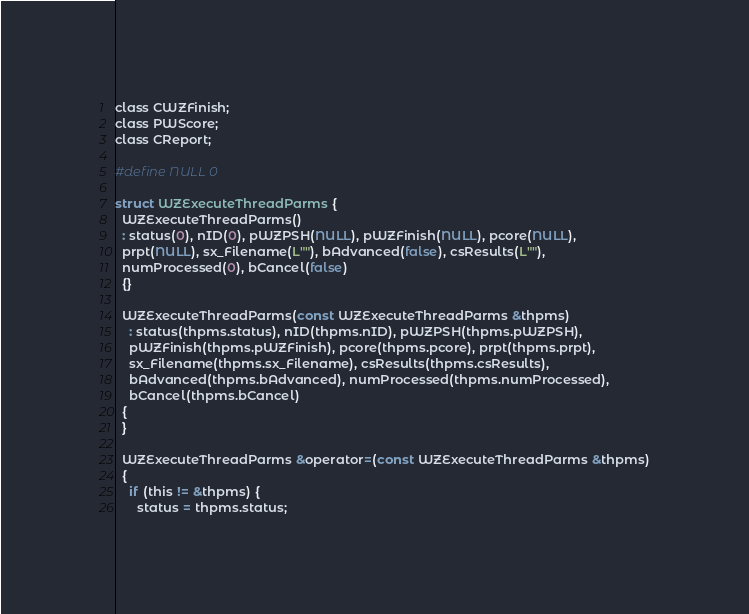<code> <loc_0><loc_0><loc_500><loc_500><_C_>class CWZFinish;
class PWScore;
class CReport;

#define NULL 0

struct WZExecuteThreadParms {
  WZExecuteThreadParms()
  : status(0), nID(0), pWZPSH(NULL), pWZFinish(NULL), pcore(NULL),
  prpt(NULL), sx_Filename(L""), bAdvanced(false), csResults(L""),
  numProcessed(0), bCancel(false)
  {}

  WZExecuteThreadParms(const WZExecuteThreadParms &thpms)
    : status(thpms.status), nID(thpms.nID), pWZPSH(thpms.pWZPSH),
    pWZFinish(thpms.pWZFinish), pcore(thpms.pcore), prpt(thpms.prpt),
    sx_Filename(thpms.sx_Filename), csResults(thpms.csResults),
    bAdvanced(thpms.bAdvanced), numProcessed(thpms.numProcessed),
    bCancel(thpms.bCancel)
  {
  }

  WZExecuteThreadParms &operator=(const WZExecuteThreadParms &thpms)
  {
    if (this != &thpms) {
      status = thpms.status;</code> 